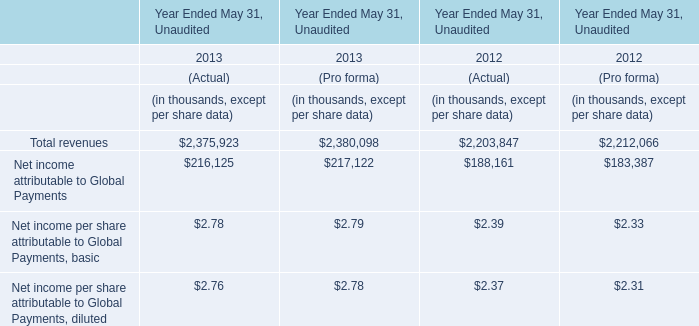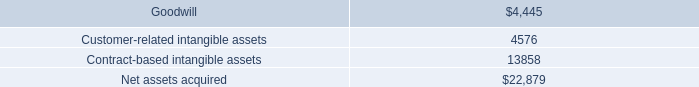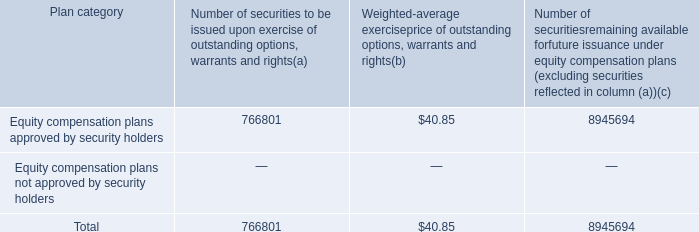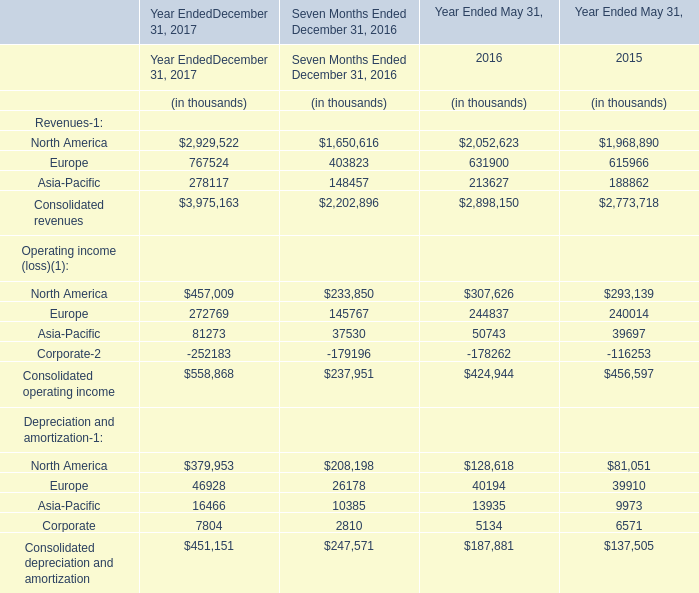If Consolidated operating incomedevelops with the same growth rate in 2016, what will it reach in 2017? (in thousand) 
Computations: ((1 + ((424944 - 456597) / 456597)) * 424944)
Answer: 395485.30353. 